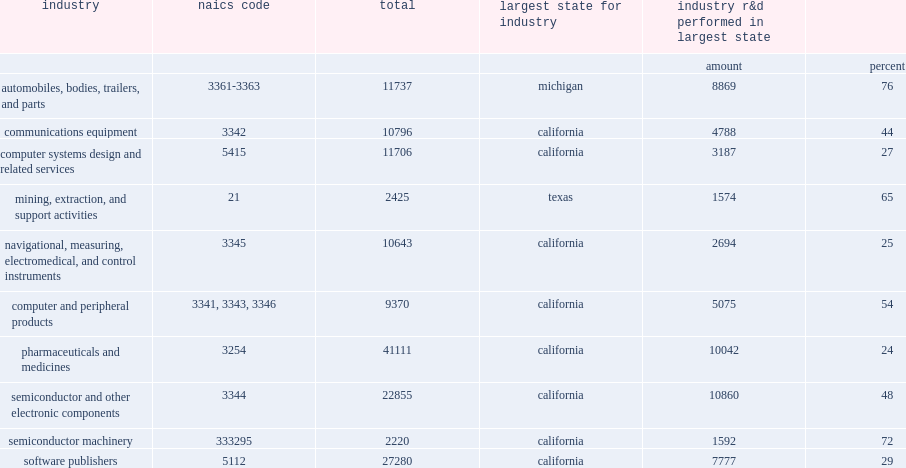Give me the full table as a dictionary. {'header': ['industry', 'naics code', 'total', 'largest state for industry', 'industry r&d performed in largest state', ''], 'rows': [['', '', '', '', 'amount', 'percent'], ['automobiles, bodies, trailers, and parts', '3361-3363', '11737', 'michigan', '8869', '76'], ['communications equipment', '3342', '10796', 'california', '4788', '44'], ['computer systems design and related services', '5415', '11706', 'california', '3187', '27'], ['mining, extraction, and support activities', '21', '2425', 'texas', '1574', '65'], ['navigational, measuring, electromedical, and control instruments', '3345', '10643', 'california', '2694', '25'], ['computer and peripheral products', '3341, 3343, 3346', '9370', 'california', '5075', '54'], ['pharmaceuticals and medicines', '3254', '41111', 'california', '10042', '24'], ['semiconductor and other electronic components', '3344', '22855', 'california', '10860', '48'], ['semiconductor machinery', '333295', '2220', 'california', '1592', '72'], ['software publishers', '5112', '27280', 'california', '7777', '29']]} How many percent does california account of the semiconductor machinery manufacturing? 72.0. How many percent does california account of the computer and peripheral products industries? 54.0. How many percent does california account of the semiconductor and other electronic components industry? 48.0. How many percent did michigan account for the majority of r&d performed by automobile manufacturers in the united states? 76.0. How many percent did the r&d of the mining, extraction, and support industries, including that of oil and gas companies, was concentrated in texas account of self-funded u.s. r&d performance? 65.0. 